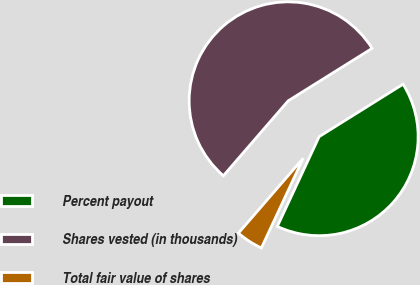Convert chart to OTSL. <chart><loc_0><loc_0><loc_500><loc_500><pie_chart><fcel>Percent payout<fcel>Shares vested (in thousands)<fcel>Total fair value of shares<nl><fcel>40.83%<fcel>54.76%<fcel>4.41%<nl></chart> 